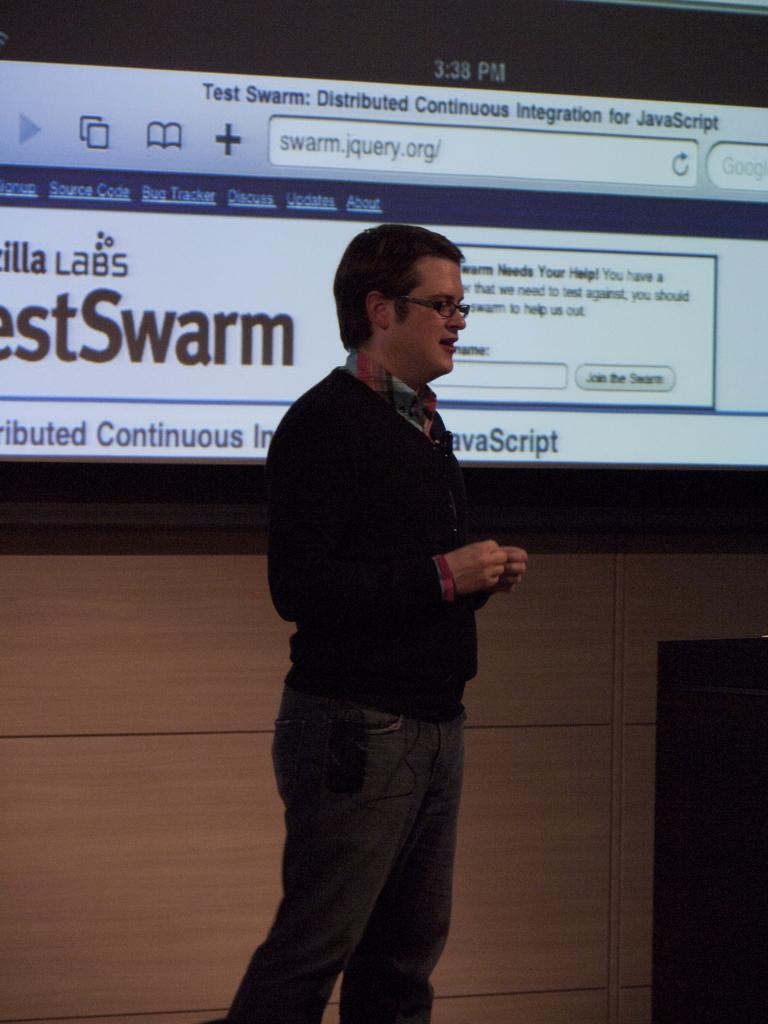What is the main subject of the image? There is a person standing and talking in the center of the image. What object can be seen on the right side of the image? There is a podium on the right side of the image. What is in the background of the image? There is a projector screen in the background of the image. What type of rate is being discussed by the person in the image? There is no indication in the image of any specific rate being discussed. Can you see a tank in the image? No, there is no tank present in the image. 